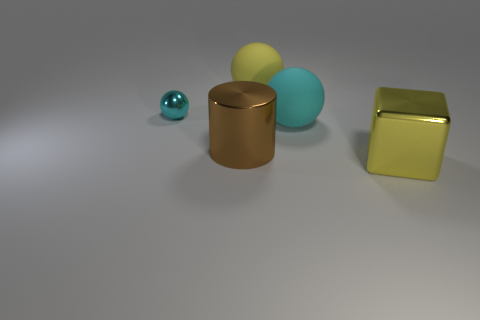There is a metal cylinder that is the same size as the metallic block; what color is it?
Offer a terse response. Brown. Is there a big metal block that has the same color as the tiny ball?
Keep it short and to the point. No. Is the color of the thing left of the metal cylinder the same as the sphere to the right of the yellow sphere?
Provide a succinct answer. Yes. There is a brown thing that is behind the large block; what material is it?
Offer a terse response. Metal. The big thing that is the same material as the large brown cylinder is what color?
Offer a very short reply. Yellow. What number of cylinders have the same size as the metallic block?
Provide a short and direct response. 1. There is a ball that is left of the yellow ball; is it the same size as the large yellow metallic object?
Provide a succinct answer. No. The metallic object that is behind the yellow block and in front of the tiny cyan metal object has what shape?
Provide a succinct answer. Cylinder. Are there any big yellow metal objects behind the tiny shiny sphere?
Make the answer very short. No. Is there anything else that is the same shape as the small object?
Provide a succinct answer. Yes. 